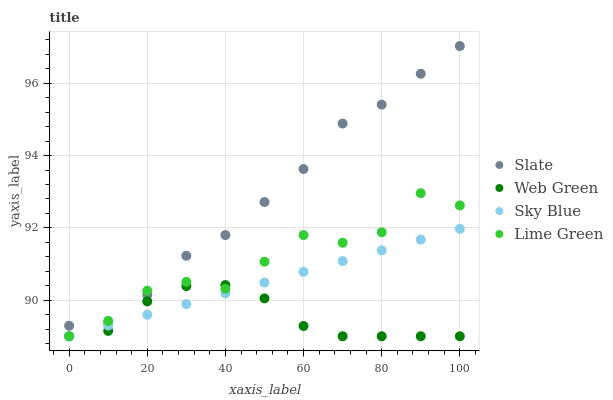Does Web Green have the minimum area under the curve?
Answer yes or no. Yes. Does Slate have the maximum area under the curve?
Answer yes or no. Yes. Does Lime Green have the minimum area under the curve?
Answer yes or no. No. Does Lime Green have the maximum area under the curve?
Answer yes or no. No. Is Sky Blue the smoothest?
Answer yes or no. Yes. Is Lime Green the roughest?
Answer yes or no. Yes. Is Slate the smoothest?
Answer yes or no. No. Is Slate the roughest?
Answer yes or no. No. Does Sky Blue have the lowest value?
Answer yes or no. Yes. Does Slate have the lowest value?
Answer yes or no. No. Does Slate have the highest value?
Answer yes or no. Yes. Does Lime Green have the highest value?
Answer yes or no. No. Is Web Green less than Slate?
Answer yes or no. Yes. Is Slate greater than Web Green?
Answer yes or no. Yes. Does Sky Blue intersect Web Green?
Answer yes or no. Yes. Is Sky Blue less than Web Green?
Answer yes or no. No. Is Sky Blue greater than Web Green?
Answer yes or no. No. Does Web Green intersect Slate?
Answer yes or no. No. 